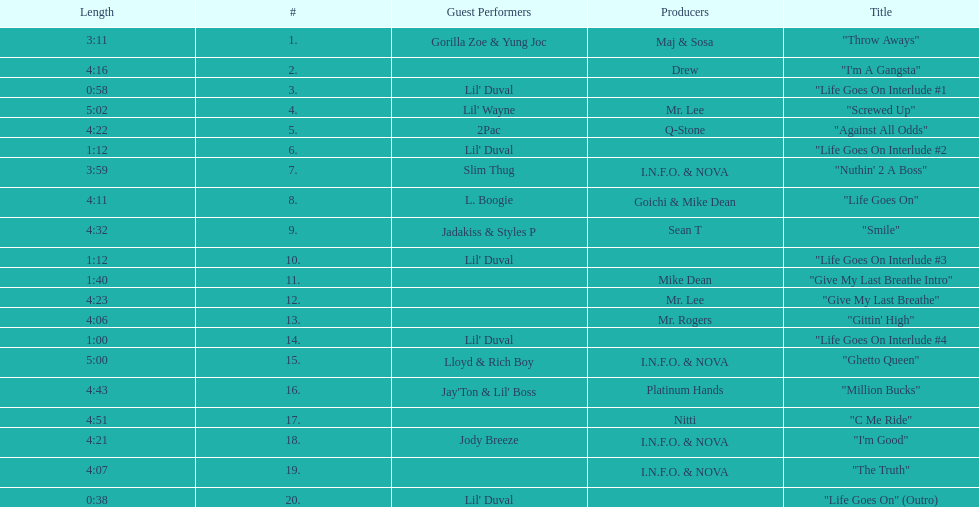What is the first track featuring lil' duval? "Life Goes On Interlude #1. 